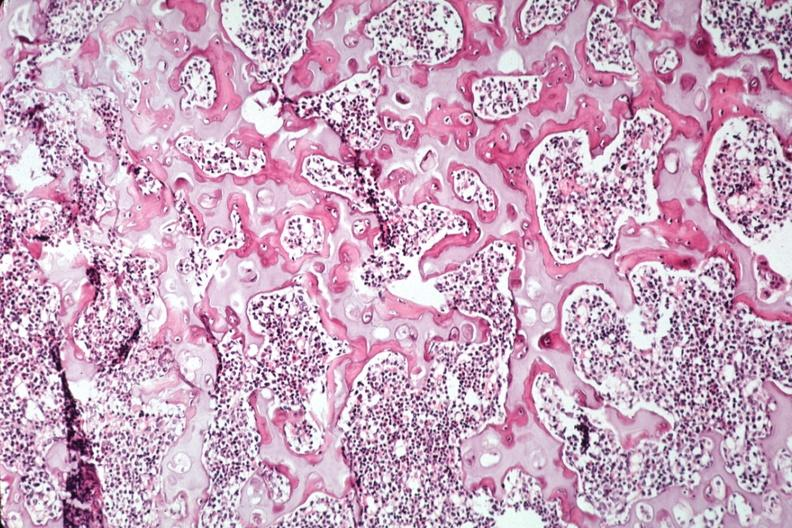s joints present?
Answer the question using a single word or phrase. Yes 